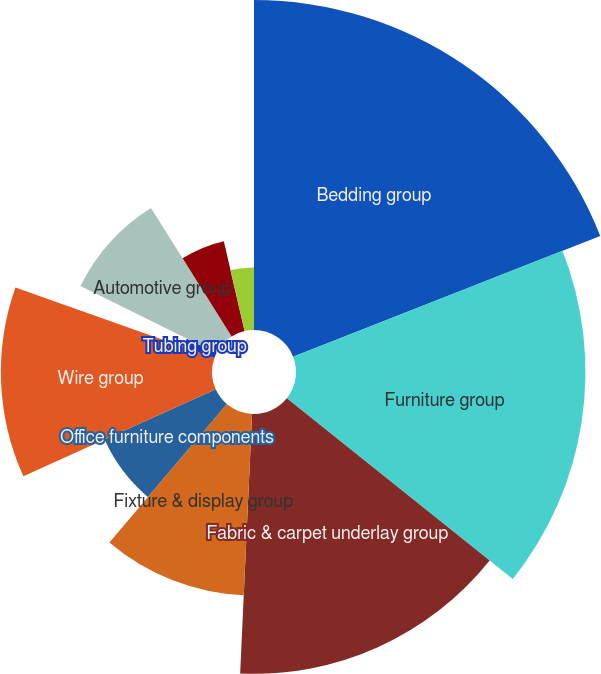<chart> <loc_0><loc_0><loc_500><loc_500><pie_chart><fcel>Bedding group<fcel>Furniture group<fcel>Fabric & carpet underlay group<fcel>Fixture & display group<fcel>Office furniture components<fcel>Wire group<fcel>Tubing group<fcel>Automotive group<fcel>Commercial vehicle products<fcel>Machinery group<nl><fcel>19.04%<fcel>16.7%<fcel>14.99%<fcel>10.47%<fcel>7.04%<fcel>12.18%<fcel>1.9%<fcel>8.75%<fcel>5.32%<fcel>3.61%<nl></chart> 